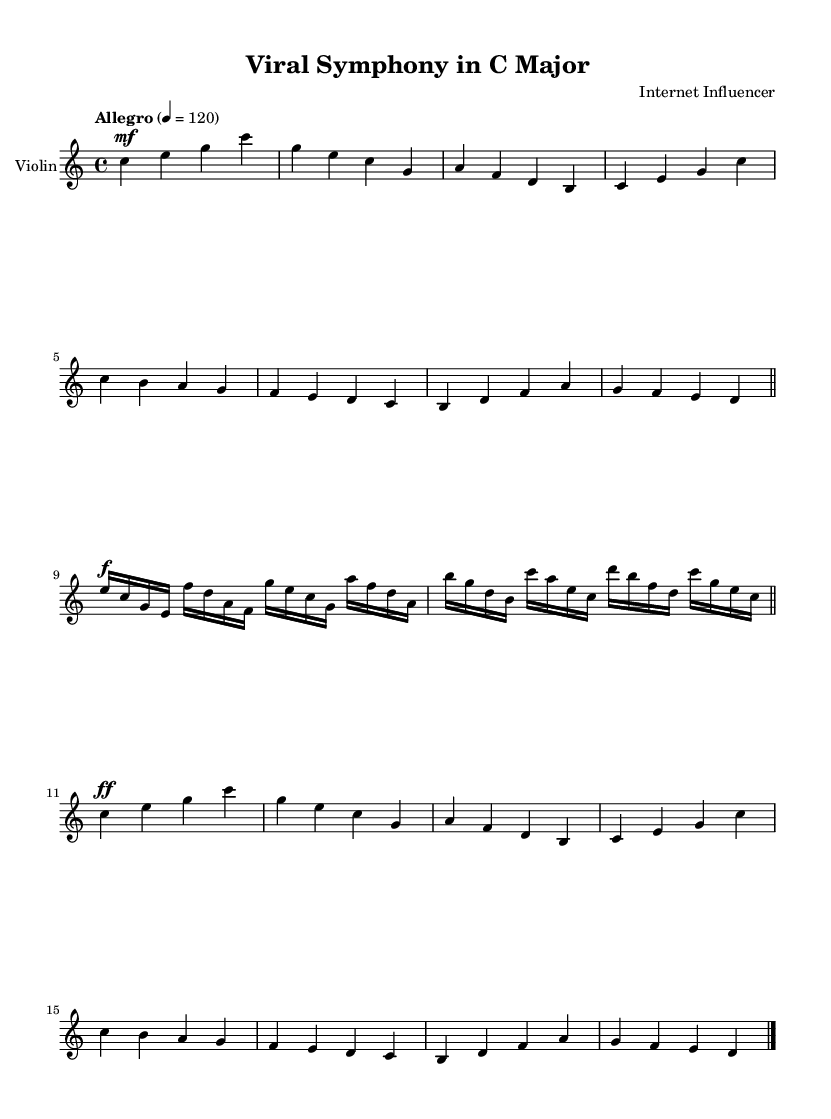What is the key signature of this music? The key signature indicates that this piece is in C major, which has no sharps or flats. This can be confirmed by looking at the key signature placed at the beginning of the staff.
Answer: C major What is the time signature of the piece? The time signature is 4/4, meaning there are four beats in each measure, and the quarter note gets one beat. This is indicated at the beginning of the score.
Answer: 4/4 What is the tempo marking of this piece? The tempo marking is "Allegro," which indicates a fast and lively tempo. The metronome marking "4 = 120" is also present, indicating that there are 120 beats per minute.
Answer: Allegro How many measures are in the first section of the music? The first section of music consists of four measures, as visible from the grouping of the notes and the bar lines that separate each measure.
Answer: Four What dynamic marking is used at the beginning of the second section? The second section begins with a dynamic marking of "f" for forte, which indicates that this part should be played loudly. This can be identified at the start of the second section of notes.
Answer: Forte What is the last note of the composition? The last note of the composition is a C, as it appears at the end of the final measure and is the resolution of the piece. This can be confirmed by looking at the final note in the last measure.
Answer: C 